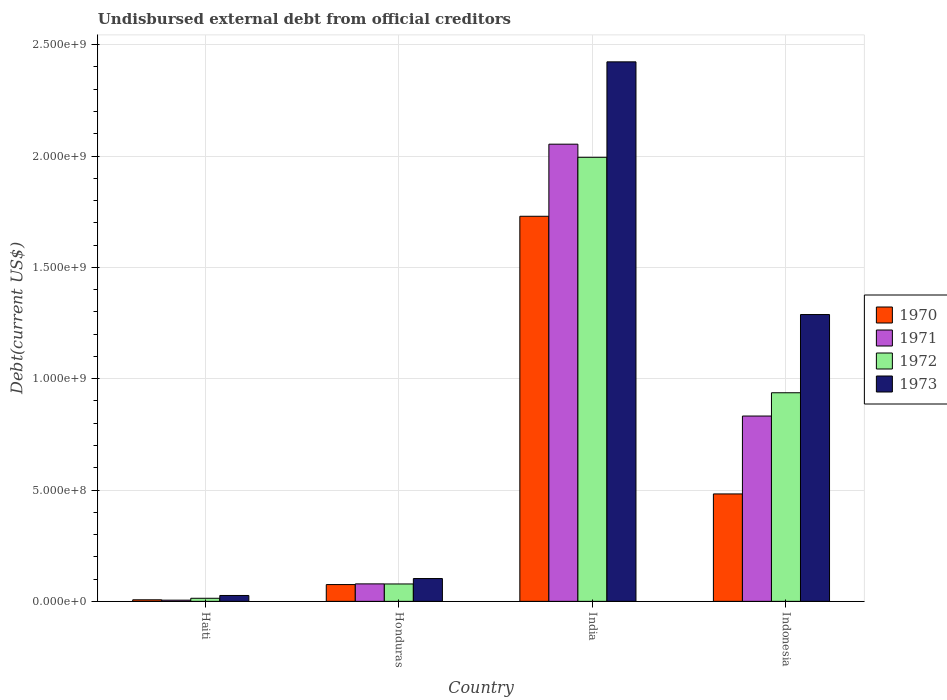How many groups of bars are there?
Your response must be concise. 4. How many bars are there on the 3rd tick from the left?
Your answer should be compact. 4. How many bars are there on the 4th tick from the right?
Your response must be concise. 4. What is the label of the 2nd group of bars from the left?
Your answer should be compact. Honduras. In how many cases, is the number of bars for a given country not equal to the number of legend labels?
Provide a short and direct response. 0. What is the total debt in 1971 in Indonesia?
Your answer should be very brief. 8.32e+08. Across all countries, what is the maximum total debt in 1970?
Provide a short and direct response. 1.73e+09. Across all countries, what is the minimum total debt in 1973?
Ensure brevity in your answer.  2.64e+07. In which country was the total debt in 1972 minimum?
Your answer should be compact. Haiti. What is the total total debt in 1972 in the graph?
Give a very brief answer. 3.02e+09. What is the difference between the total debt in 1971 in Honduras and that in Indonesia?
Your answer should be very brief. -7.54e+08. What is the difference between the total debt in 1973 in Indonesia and the total debt in 1971 in Honduras?
Provide a short and direct response. 1.21e+09. What is the average total debt in 1972 per country?
Provide a succinct answer. 7.56e+08. What is the difference between the total debt of/in 1971 and total debt of/in 1973 in Haiti?
Your answer should be very brief. -2.11e+07. In how many countries, is the total debt in 1973 greater than 900000000 US$?
Offer a terse response. 2. What is the ratio of the total debt in 1970 in Haiti to that in Indonesia?
Make the answer very short. 0.01. What is the difference between the highest and the second highest total debt in 1971?
Your answer should be very brief. -1.22e+09. What is the difference between the highest and the lowest total debt in 1973?
Give a very brief answer. 2.40e+09. In how many countries, is the total debt in 1971 greater than the average total debt in 1971 taken over all countries?
Provide a succinct answer. 2. Is the sum of the total debt in 1972 in Haiti and Honduras greater than the maximum total debt in 1973 across all countries?
Keep it short and to the point. No. Is it the case that in every country, the sum of the total debt in 1973 and total debt in 1970 is greater than the sum of total debt in 1971 and total debt in 1972?
Your answer should be very brief. No. What does the 2nd bar from the left in Haiti represents?
Ensure brevity in your answer.  1971. What does the 3rd bar from the right in Indonesia represents?
Your answer should be very brief. 1971. Are all the bars in the graph horizontal?
Keep it short and to the point. No. How many countries are there in the graph?
Provide a succinct answer. 4. Are the values on the major ticks of Y-axis written in scientific E-notation?
Make the answer very short. Yes. Does the graph contain any zero values?
Keep it short and to the point. No. Does the graph contain grids?
Your answer should be very brief. Yes. Where does the legend appear in the graph?
Give a very brief answer. Center right. What is the title of the graph?
Ensure brevity in your answer.  Undisbursed external debt from official creditors. What is the label or title of the Y-axis?
Offer a terse response. Debt(current US$). What is the Debt(current US$) of 1970 in Haiti?
Provide a succinct answer. 6.96e+06. What is the Debt(current US$) of 1971 in Haiti?
Ensure brevity in your answer.  5.35e+06. What is the Debt(current US$) in 1972 in Haiti?
Make the answer very short. 1.39e+07. What is the Debt(current US$) of 1973 in Haiti?
Offer a very short reply. 2.64e+07. What is the Debt(current US$) in 1970 in Honduras?
Provide a short and direct response. 7.54e+07. What is the Debt(current US$) of 1971 in Honduras?
Your answer should be very brief. 7.85e+07. What is the Debt(current US$) in 1972 in Honduras?
Provide a succinct answer. 7.81e+07. What is the Debt(current US$) in 1973 in Honduras?
Provide a succinct answer. 1.02e+08. What is the Debt(current US$) in 1970 in India?
Ensure brevity in your answer.  1.73e+09. What is the Debt(current US$) in 1971 in India?
Provide a short and direct response. 2.05e+09. What is the Debt(current US$) in 1972 in India?
Provide a short and direct response. 1.99e+09. What is the Debt(current US$) in 1973 in India?
Offer a terse response. 2.42e+09. What is the Debt(current US$) in 1970 in Indonesia?
Provide a short and direct response. 4.82e+08. What is the Debt(current US$) of 1971 in Indonesia?
Offer a terse response. 8.32e+08. What is the Debt(current US$) of 1972 in Indonesia?
Offer a very short reply. 9.37e+08. What is the Debt(current US$) in 1973 in Indonesia?
Offer a very short reply. 1.29e+09. Across all countries, what is the maximum Debt(current US$) of 1970?
Give a very brief answer. 1.73e+09. Across all countries, what is the maximum Debt(current US$) in 1971?
Keep it short and to the point. 2.05e+09. Across all countries, what is the maximum Debt(current US$) of 1972?
Keep it short and to the point. 1.99e+09. Across all countries, what is the maximum Debt(current US$) of 1973?
Ensure brevity in your answer.  2.42e+09. Across all countries, what is the minimum Debt(current US$) in 1970?
Provide a short and direct response. 6.96e+06. Across all countries, what is the minimum Debt(current US$) of 1971?
Ensure brevity in your answer.  5.35e+06. Across all countries, what is the minimum Debt(current US$) in 1972?
Make the answer very short. 1.39e+07. Across all countries, what is the minimum Debt(current US$) in 1973?
Your answer should be very brief. 2.64e+07. What is the total Debt(current US$) in 1970 in the graph?
Your response must be concise. 2.29e+09. What is the total Debt(current US$) of 1971 in the graph?
Offer a terse response. 2.97e+09. What is the total Debt(current US$) in 1972 in the graph?
Make the answer very short. 3.02e+09. What is the total Debt(current US$) in 1973 in the graph?
Your response must be concise. 3.84e+09. What is the difference between the Debt(current US$) in 1970 in Haiti and that in Honduras?
Provide a succinct answer. -6.84e+07. What is the difference between the Debt(current US$) in 1971 in Haiti and that in Honduras?
Keep it short and to the point. -7.31e+07. What is the difference between the Debt(current US$) of 1972 in Haiti and that in Honduras?
Your answer should be compact. -6.42e+07. What is the difference between the Debt(current US$) in 1973 in Haiti and that in Honduras?
Make the answer very short. -7.61e+07. What is the difference between the Debt(current US$) in 1970 in Haiti and that in India?
Your answer should be very brief. -1.72e+09. What is the difference between the Debt(current US$) in 1971 in Haiti and that in India?
Your answer should be compact. -2.05e+09. What is the difference between the Debt(current US$) in 1972 in Haiti and that in India?
Your response must be concise. -1.98e+09. What is the difference between the Debt(current US$) in 1973 in Haiti and that in India?
Ensure brevity in your answer.  -2.40e+09. What is the difference between the Debt(current US$) of 1970 in Haiti and that in Indonesia?
Your answer should be compact. -4.75e+08. What is the difference between the Debt(current US$) in 1971 in Haiti and that in Indonesia?
Provide a succinct answer. -8.27e+08. What is the difference between the Debt(current US$) in 1972 in Haiti and that in Indonesia?
Your answer should be compact. -9.23e+08. What is the difference between the Debt(current US$) in 1973 in Haiti and that in Indonesia?
Ensure brevity in your answer.  -1.26e+09. What is the difference between the Debt(current US$) of 1970 in Honduras and that in India?
Keep it short and to the point. -1.65e+09. What is the difference between the Debt(current US$) of 1971 in Honduras and that in India?
Provide a short and direct response. -1.97e+09. What is the difference between the Debt(current US$) of 1972 in Honduras and that in India?
Your response must be concise. -1.92e+09. What is the difference between the Debt(current US$) in 1973 in Honduras and that in India?
Make the answer very short. -2.32e+09. What is the difference between the Debt(current US$) of 1970 in Honduras and that in Indonesia?
Keep it short and to the point. -4.07e+08. What is the difference between the Debt(current US$) of 1971 in Honduras and that in Indonesia?
Your answer should be very brief. -7.54e+08. What is the difference between the Debt(current US$) of 1972 in Honduras and that in Indonesia?
Provide a succinct answer. -8.59e+08. What is the difference between the Debt(current US$) in 1973 in Honduras and that in Indonesia?
Make the answer very short. -1.19e+09. What is the difference between the Debt(current US$) in 1970 in India and that in Indonesia?
Offer a very short reply. 1.25e+09. What is the difference between the Debt(current US$) of 1971 in India and that in Indonesia?
Your answer should be very brief. 1.22e+09. What is the difference between the Debt(current US$) in 1972 in India and that in Indonesia?
Keep it short and to the point. 1.06e+09. What is the difference between the Debt(current US$) in 1973 in India and that in Indonesia?
Provide a short and direct response. 1.13e+09. What is the difference between the Debt(current US$) in 1970 in Haiti and the Debt(current US$) in 1971 in Honduras?
Your answer should be compact. -7.15e+07. What is the difference between the Debt(current US$) of 1970 in Haiti and the Debt(current US$) of 1972 in Honduras?
Ensure brevity in your answer.  -7.12e+07. What is the difference between the Debt(current US$) in 1970 in Haiti and the Debt(current US$) in 1973 in Honduras?
Provide a short and direct response. -9.55e+07. What is the difference between the Debt(current US$) of 1971 in Haiti and the Debt(current US$) of 1972 in Honduras?
Provide a short and direct response. -7.28e+07. What is the difference between the Debt(current US$) of 1971 in Haiti and the Debt(current US$) of 1973 in Honduras?
Provide a succinct answer. -9.71e+07. What is the difference between the Debt(current US$) in 1972 in Haiti and the Debt(current US$) in 1973 in Honduras?
Keep it short and to the point. -8.86e+07. What is the difference between the Debt(current US$) of 1970 in Haiti and the Debt(current US$) of 1971 in India?
Your response must be concise. -2.05e+09. What is the difference between the Debt(current US$) in 1970 in Haiti and the Debt(current US$) in 1972 in India?
Your answer should be compact. -1.99e+09. What is the difference between the Debt(current US$) of 1970 in Haiti and the Debt(current US$) of 1973 in India?
Give a very brief answer. -2.42e+09. What is the difference between the Debt(current US$) in 1971 in Haiti and the Debt(current US$) in 1972 in India?
Give a very brief answer. -1.99e+09. What is the difference between the Debt(current US$) in 1971 in Haiti and the Debt(current US$) in 1973 in India?
Make the answer very short. -2.42e+09. What is the difference between the Debt(current US$) in 1972 in Haiti and the Debt(current US$) in 1973 in India?
Provide a short and direct response. -2.41e+09. What is the difference between the Debt(current US$) of 1970 in Haiti and the Debt(current US$) of 1971 in Indonesia?
Offer a terse response. -8.25e+08. What is the difference between the Debt(current US$) in 1970 in Haiti and the Debt(current US$) in 1972 in Indonesia?
Offer a very short reply. -9.30e+08. What is the difference between the Debt(current US$) of 1970 in Haiti and the Debt(current US$) of 1973 in Indonesia?
Your response must be concise. -1.28e+09. What is the difference between the Debt(current US$) of 1971 in Haiti and the Debt(current US$) of 1972 in Indonesia?
Provide a short and direct response. -9.31e+08. What is the difference between the Debt(current US$) in 1971 in Haiti and the Debt(current US$) in 1973 in Indonesia?
Your response must be concise. -1.28e+09. What is the difference between the Debt(current US$) of 1972 in Haiti and the Debt(current US$) of 1973 in Indonesia?
Make the answer very short. -1.27e+09. What is the difference between the Debt(current US$) in 1970 in Honduras and the Debt(current US$) in 1971 in India?
Ensure brevity in your answer.  -1.98e+09. What is the difference between the Debt(current US$) of 1970 in Honduras and the Debt(current US$) of 1972 in India?
Provide a short and direct response. -1.92e+09. What is the difference between the Debt(current US$) of 1970 in Honduras and the Debt(current US$) of 1973 in India?
Keep it short and to the point. -2.35e+09. What is the difference between the Debt(current US$) of 1971 in Honduras and the Debt(current US$) of 1972 in India?
Your answer should be compact. -1.92e+09. What is the difference between the Debt(current US$) of 1971 in Honduras and the Debt(current US$) of 1973 in India?
Keep it short and to the point. -2.34e+09. What is the difference between the Debt(current US$) in 1972 in Honduras and the Debt(current US$) in 1973 in India?
Provide a short and direct response. -2.34e+09. What is the difference between the Debt(current US$) of 1970 in Honduras and the Debt(current US$) of 1971 in Indonesia?
Provide a succinct answer. -7.57e+08. What is the difference between the Debt(current US$) in 1970 in Honduras and the Debt(current US$) in 1972 in Indonesia?
Offer a very short reply. -8.61e+08. What is the difference between the Debt(current US$) of 1970 in Honduras and the Debt(current US$) of 1973 in Indonesia?
Your answer should be very brief. -1.21e+09. What is the difference between the Debt(current US$) of 1971 in Honduras and the Debt(current US$) of 1972 in Indonesia?
Your answer should be compact. -8.58e+08. What is the difference between the Debt(current US$) of 1971 in Honduras and the Debt(current US$) of 1973 in Indonesia?
Ensure brevity in your answer.  -1.21e+09. What is the difference between the Debt(current US$) in 1972 in Honduras and the Debt(current US$) in 1973 in Indonesia?
Keep it short and to the point. -1.21e+09. What is the difference between the Debt(current US$) in 1970 in India and the Debt(current US$) in 1971 in Indonesia?
Give a very brief answer. 8.97e+08. What is the difference between the Debt(current US$) of 1970 in India and the Debt(current US$) of 1972 in Indonesia?
Offer a terse response. 7.93e+08. What is the difference between the Debt(current US$) of 1970 in India and the Debt(current US$) of 1973 in Indonesia?
Keep it short and to the point. 4.41e+08. What is the difference between the Debt(current US$) of 1971 in India and the Debt(current US$) of 1972 in Indonesia?
Your answer should be very brief. 1.12e+09. What is the difference between the Debt(current US$) in 1971 in India and the Debt(current US$) in 1973 in Indonesia?
Make the answer very short. 7.65e+08. What is the difference between the Debt(current US$) in 1972 in India and the Debt(current US$) in 1973 in Indonesia?
Your response must be concise. 7.06e+08. What is the average Debt(current US$) of 1970 per country?
Your answer should be very brief. 5.74e+08. What is the average Debt(current US$) of 1971 per country?
Keep it short and to the point. 7.42e+08. What is the average Debt(current US$) in 1972 per country?
Ensure brevity in your answer.  7.56e+08. What is the average Debt(current US$) of 1973 per country?
Make the answer very short. 9.60e+08. What is the difference between the Debt(current US$) in 1970 and Debt(current US$) in 1971 in Haiti?
Give a very brief answer. 1.61e+06. What is the difference between the Debt(current US$) in 1970 and Debt(current US$) in 1972 in Haiti?
Offer a terse response. -6.92e+06. What is the difference between the Debt(current US$) in 1970 and Debt(current US$) in 1973 in Haiti?
Your answer should be very brief. -1.95e+07. What is the difference between the Debt(current US$) in 1971 and Debt(current US$) in 1972 in Haiti?
Make the answer very short. -8.53e+06. What is the difference between the Debt(current US$) in 1971 and Debt(current US$) in 1973 in Haiti?
Your answer should be very brief. -2.11e+07. What is the difference between the Debt(current US$) of 1972 and Debt(current US$) of 1973 in Haiti?
Your response must be concise. -1.25e+07. What is the difference between the Debt(current US$) in 1970 and Debt(current US$) in 1971 in Honduras?
Your response must be concise. -3.06e+06. What is the difference between the Debt(current US$) of 1970 and Debt(current US$) of 1972 in Honduras?
Provide a short and direct response. -2.72e+06. What is the difference between the Debt(current US$) of 1970 and Debt(current US$) of 1973 in Honduras?
Offer a very short reply. -2.71e+07. What is the difference between the Debt(current US$) of 1971 and Debt(current US$) of 1972 in Honduras?
Make the answer very short. 3.37e+05. What is the difference between the Debt(current US$) of 1971 and Debt(current US$) of 1973 in Honduras?
Ensure brevity in your answer.  -2.40e+07. What is the difference between the Debt(current US$) in 1972 and Debt(current US$) in 1973 in Honduras?
Offer a terse response. -2.44e+07. What is the difference between the Debt(current US$) in 1970 and Debt(current US$) in 1971 in India?
Your answer should be very brief. -3.24e+08. What is the difference between the Debt(current US$) in 1970 and Debt(current US$) in 1972 in India?
Ensure brevity in your answer.  -2.65e+08. What is the difference between the Debt(current US$) of 1970 and Debt(current US$) of 1973 in India?
Provide a short and direct response. -6.94e+08. What is the difference between the Debt(current US$) of 1971 and Debt(current US$) of 1972 in India?
Ensure brevity in your answer.  5.89e+07. What is the difference between the Debt(current US$) in 1971 and Debt(current US$) in 1973 in India?
Ensure brevity in your answer.  -3.70e+08. What is the difference between the Debt(current US$) in 1972 and Debt(current US$) in 1973 in India?
Provide a succinct answer. -4.29e+08. What is the difference between the Debt(current US$) in 1970 and Debt(current US$) in 1971 in Indonesia?
Offer a very short reply. -3.50e+08. What is the difference between the Debt(current US$) in 1970 and Debt(current US$) in 1972 in Indonesia?
Offer a very short reply. -4.54e+08. What is the difference between the Debt(current US$) of 1970 and Debt(current US$) of 1973 in Indonesia?
Make the answer very short. -8.06e+08. What is the difference between the Debt(current US$) of 1971 and Debt(current US$) of 1972 in Indonesia?
Ensure brevity in your answer.  -1.05e+08. What is the difference between the Debt(current US$) in 1971 and Debt(current US$) in 1973 in Indonesia?
Offer a very short reply. -4.56e+08. What is the difference between the Debt(current US$) in 1972 and Debt(current US$) in 1973 in Indonesia?
Your answer should be very brief. -3.51e+08. What is the ratio of the Debt(current US$) in 1970 in Haiti to that in Honduras?
Your answer should be very brief. 0.09. What is the ratio of the Debt(current US$) of 1971 in Haiti to that in Honduras?
Ensure brevity in your answer.  0.07. What is the ratio of the Debt(current US$) in 1972 in Haiti to that in Honduras?
Ensure brevity in your answer.  0.18. What is the ratio of the Debt(current US$) in 1973 in Haiti to that in Honduras?
Provide a succinct answer. 0.26. What is the ratio of the Debt(current US$) in 1970 in Haiti to that in India?
Ensure brevity in your answer.  0. What is the ratio of the Debt(current US$) in 1971 in Haiti to that in India?
Your response must be concise. 0. What is the ratio of the Debt(current US$) of 1972 in Haiti to that in India?
Provide a short and direct response. 0.01. What is the ratio of the Debt(current US$) of 1973 in Haiti to that in India?
Make the answer very short. 0.01. What is the ratio of the Debt(current US$) in 1970 in Haiti to that in Indonesia?
Offer a very short reply. 0.01. What is the ratio of the Debt(current US$) of 1971 in Haiti to that in Indonesia?
Keep it short and to the point. 0.01. What is the ratio of the Debt(current US$) in 1972 in Haiti to that in Indonesia?
Your answer should be compact. 0.01. What is the ratio of the Debt(current US$) in 1973 in Haiti to that in Indonesia?
Keep it short and to the point. 0.02. What is the ratio of the Debt(current US$) of 1970 in Honduras to that in India?
Offer a terse response. 0.04. What is the ratio of the Debt(current US$) in 1971 in Honduras to that in India?
Give a very brief answer. 0.04. What is the ratio of the Debt(current US$) of 1972 in Honduras to that in India?
Offer a terse response. 0.04. What is the ratio of the Debt(current US$) in 1973 in Honduras to that in India?
Your response must be concise. 0.04. What is the ratio of the Debt(current US$) in 1970 in Honduras to that in Indonesia?
Ensure brevity in your answer.  0.16. What is the ratio of the Debt(current US$) in 1971 in Honduras to that in Indonesia?
Make the answer very short. 0.09. What is the ratio of the Debt(current US$) in 1972 in Honduras to that in Indonesia?
Make the answer very short. 0.08. What is the ratio of the Debt(current US$) of 1973 in Honduras to that in Indonesia?
Your answer should be very brief. 0.08. What is the ratio of the Debt(current US$) of 1970 in India to that in Indonesia?
Provide a short and direct response. 3.58. What is the ratio of the Debt(current US$) of 1971 in India to that in Indonesia?
Your answer should be compact. 2.47. What is the ratio of the Debt(current US$) in 1972 in India to that in Indonesia?
Provide a short and direct response. 2.13. What is the ratio of the Debt(current US$) in 1973 in India to that in Indonesia?
Your answer should be very brief. 1.88. What is the difference between the highest and the second highest Debt(current US$) of 1970?
Your response must be concise. 1.25e+09. What is the difference between the highest and the second highest Debt(current US$) of 1971?
Provide a succinct answer. 1.22e+09. What is the difference between the highest and the second highest Debt(current US$) of 1972?
Offer a terse response. 1.06e+09. What is the difference between the highest and the second highest Debt(current US$) of 1973?
Provide a short and direct response. 1.13e+09. What is the difference between the highest and the lowest Debt(current US$) in 1970?
Offer a very short reply. 1.72e+09. What is the difference between the highest and the lowest Debt(current US$) of 1971?
Offer a terse response. 2.05e+09. What is the difference between the highest and the lowest Debt(current US$) in 1972?
Provide a succinct answer. 1.98e+09. What is the difference between the highest and the lowest Debt(current US$) in 1973?
Provide a short and direct response. 2.40e+09. 